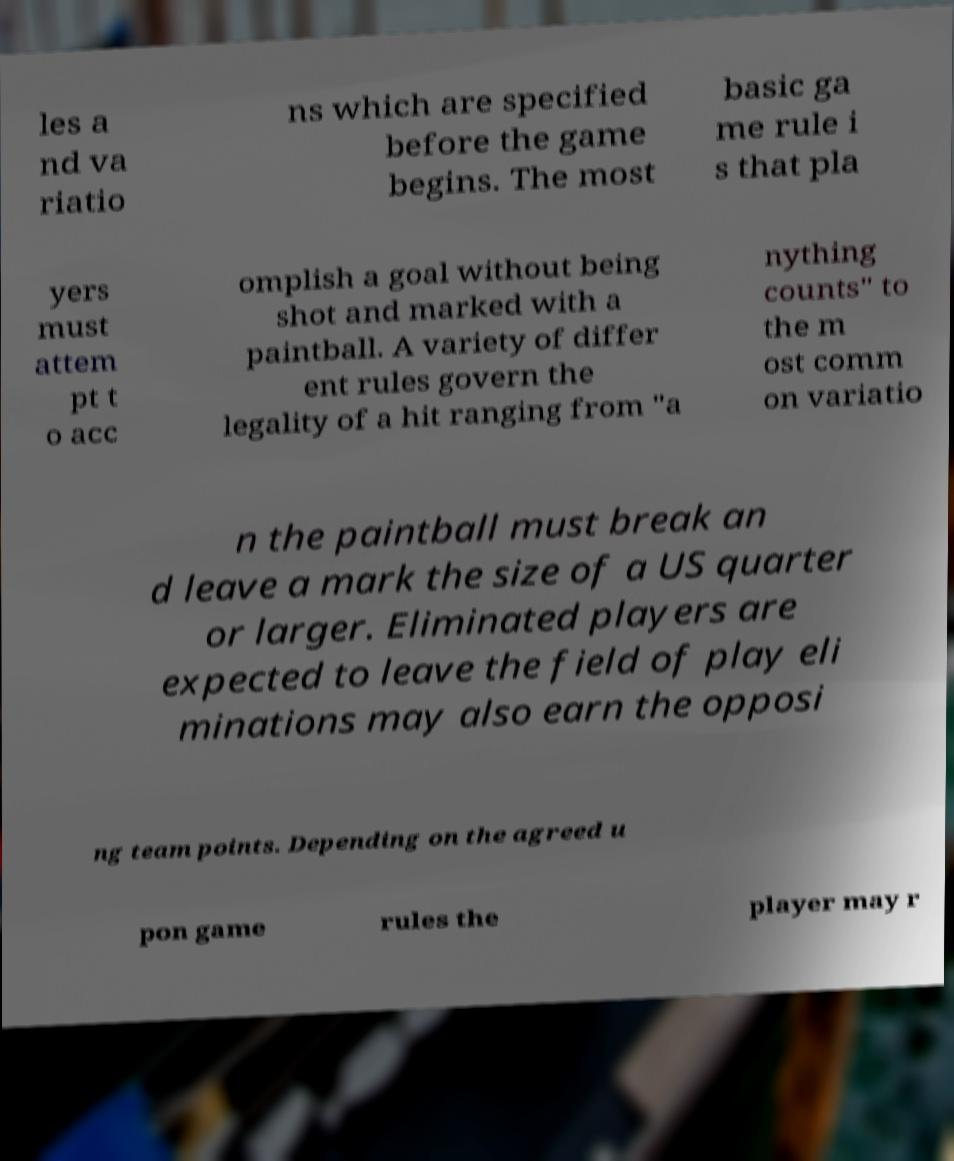What messages or text are displayed in this image? I need them in a readable, typed format. les a nd va riatio ns which are specified before the game begins. The most basic ga me rule i s that pla yers must attem pt t o acc omplish a goal without being shot and marked with a paintball. A variety of differ ent rules govern the legality of a hit ranging from "a nything counts" to the m ost comm on variatio n the paintball must break an d leave a mark the size of a US quarter or larger. Eliminated players are expected to leave the field of play eli minations may also earn the opposi ng team points. Depending on the agreed u pon game rules the player may r 